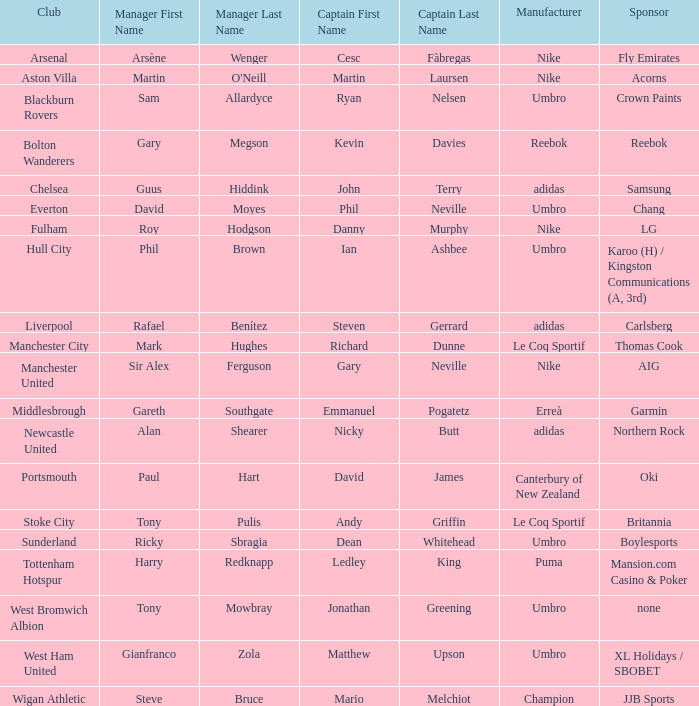Who is Dean Whitehead's manager? Ricky Sbragia. 